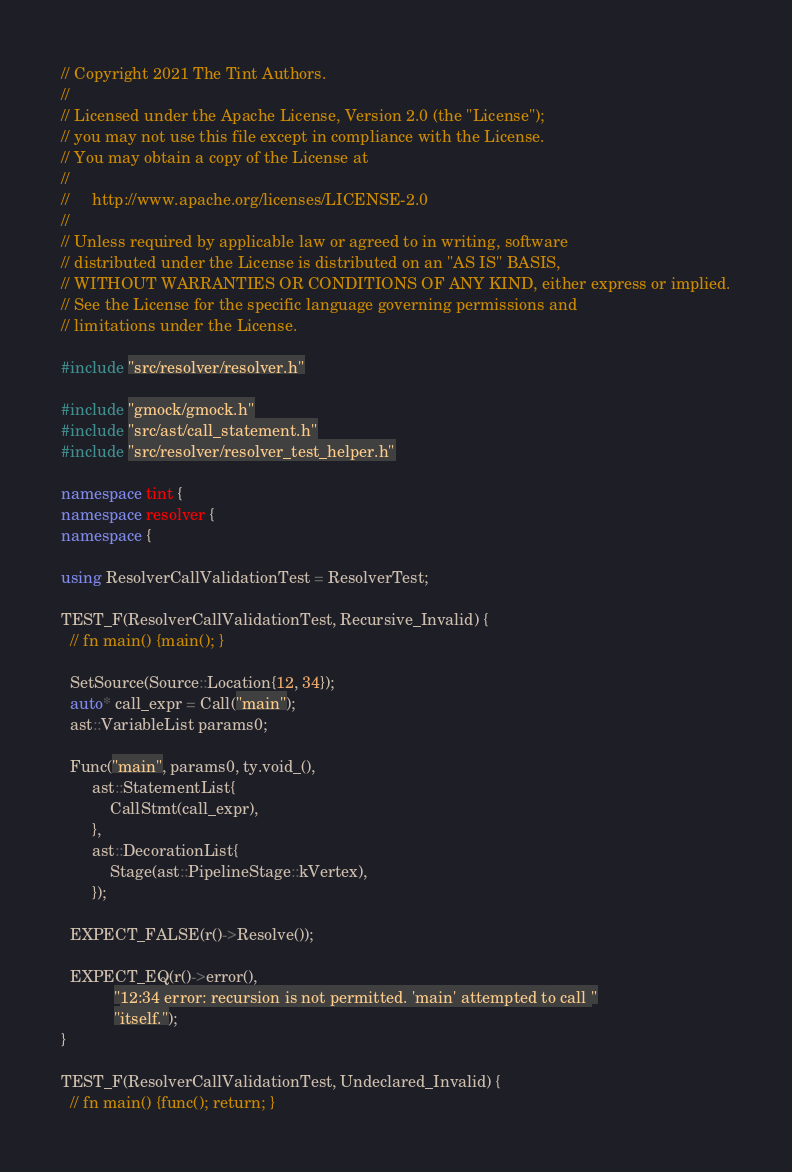<code> <loc_0><loc_0><loc_500><loc_500><_C++_>// Copyright 2021 The Tint Authors.
//
// Licensed under the Apache License, Version 2.0 (the "License");
// you may not use this file except in compliance with the License.
// You may obtain a copy of the License at
//
//     http://www.apache.org/licenses/LICENSE-2.0
//
// Unless required by applicable law or agreed to in writing, software
// distributed under the License is distributed on an "AS IS" BASIS,
// WITHOUT WARRANTIES OR CONDITIONS OF ANY KIND, either express or implied.
// See the License for the specific language governing permissions and
// limitations under the License.

#include "src/resolver/resolver.h"

#include "gmock/gmock.h"
#include "src/ast/call_statement.h"
#include "src/resolver/resolver_test_helper.h"

namespace tint {
namespace resolver {
namespace {

using ResolverCallValidationTest = ResolverTest;

TEST_F(ResolverCallValidationTest, Recursive_Invalid) {
  // fn main() {main(); }

  SetSource(Source::Location{12, 34});
  auto* call_expr = Call("main");
  ast::VariableList params0;

  Func("main", params0, ty.void_(),
       ast::StatementList{
           CallStmt(call_expr),
       },
       ast::DecorationList{
           Stage(ast::PipelineStage::kVertex),
       });

  EXPECT_FALSE(r()->Resolve());

  EXPECT_EQ(r()->error(),
            "12:34 error: recursion is not permitted. 'main' attempted to call "
            "itself.");
}

TEST_F(ResolverCallValidationTest, Undeclared_Invalid) {
  // fn main() {func(); return; }</code> 